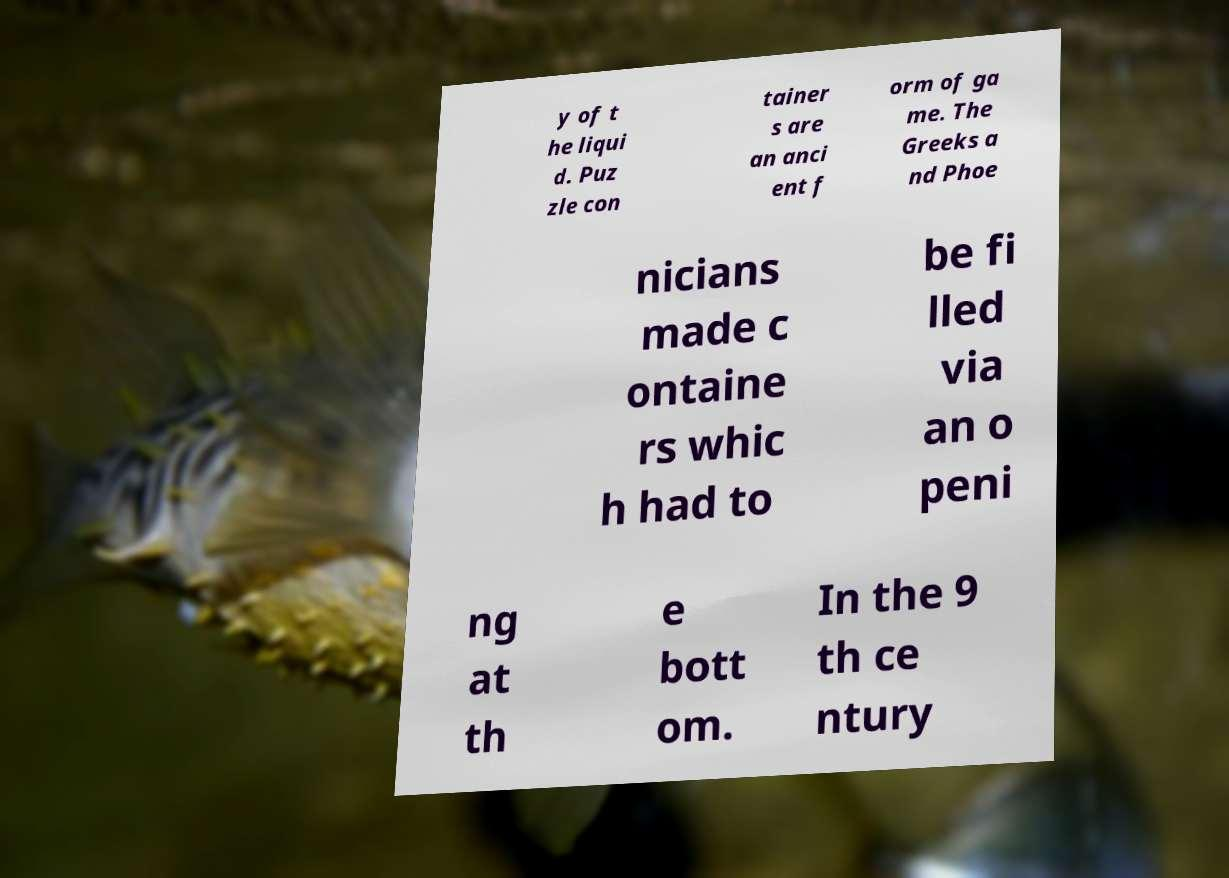Could you assist in decoding the text presented in this image and type it out clearly? y of t he liqui d. Puz zle con tainer s are an anci ent f orm of ga me. The Greeks a nd Phoe nicians made c ontaine rs whic h had to be fi lled via an o peni ng at th e bott om. In the 9 th ce ntury 